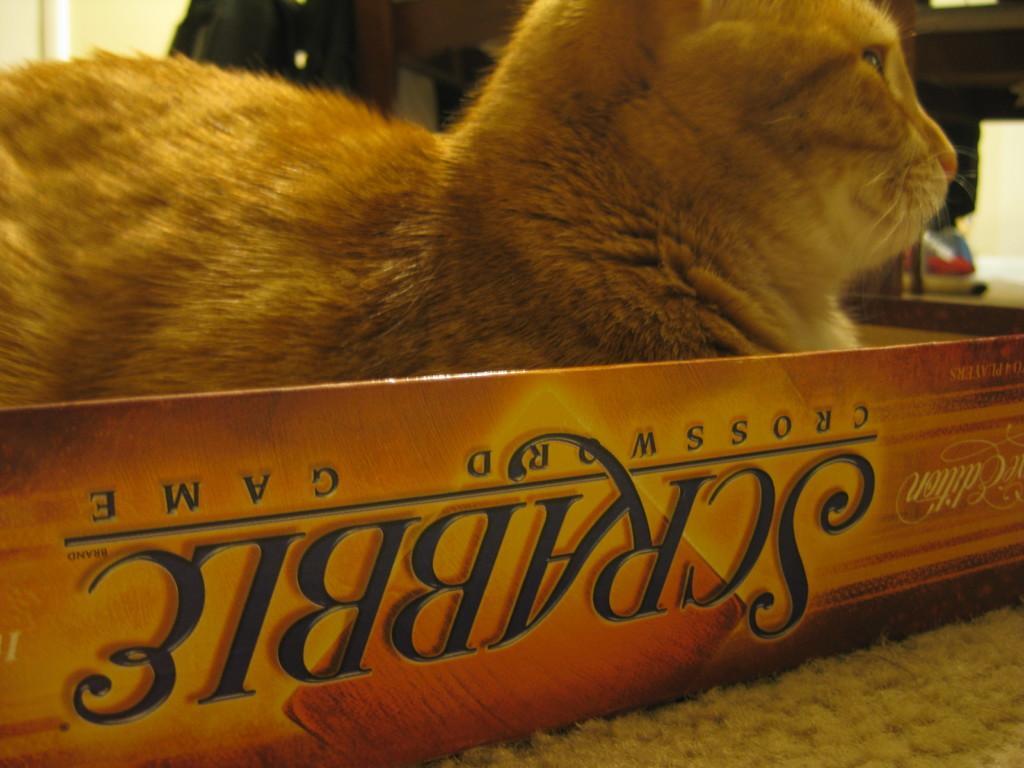How would you summarize this image in a sentence or two? At the top of this image, there is a person in a brown color cat in a box. In the background, there are some objects. And the background is white in color. 